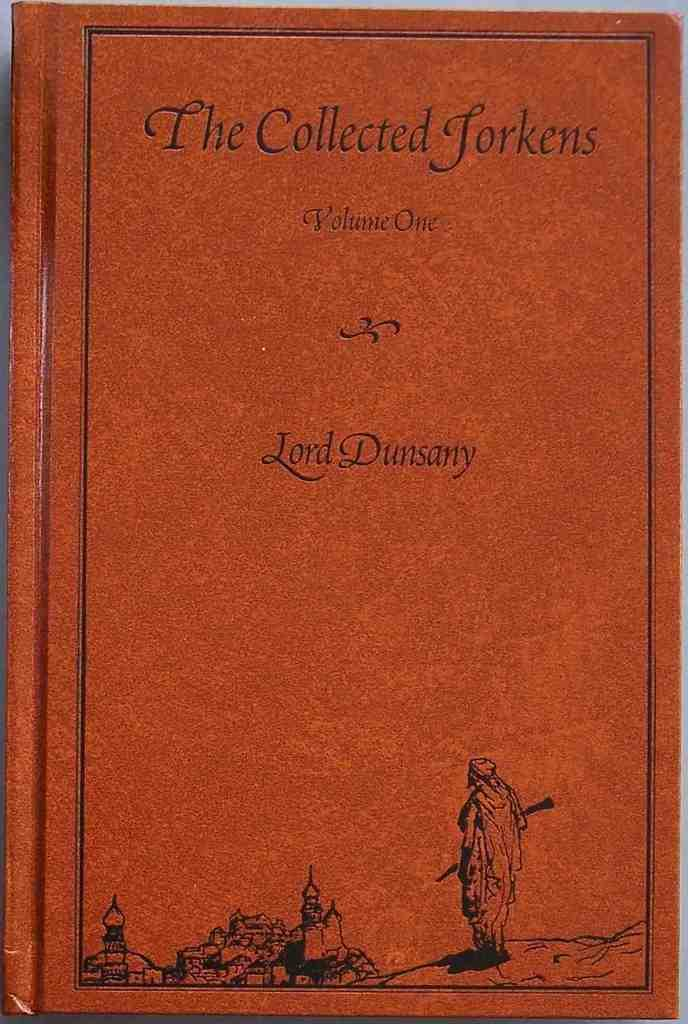<image>
Render a clear and concise summary of the photo. A red book titled the Collected Jorkens by Lord Dunsany 